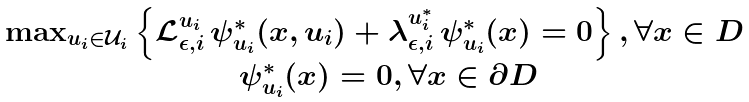Convert formula to latex. <formula><loc_0><loc_0><loc_500><loc_500>\begin{array} { c } \max _ { u _ { i } \in \mathcal { U } _ { i } } \left \{ \mathcal { L } _ { \epsilon , i } ^ { u _ { i } } \, \psi _ { u _ { i } } ^ { \ast } ( x , u _ { i } ) + \lambda _ { \epsilon , i } ^ { u _ { i } ^ { \ast } } \, \psi _ { u _ { i } } ^ { \ast } ( x ) = 0 \right \} , \forall x \in D \\ \quad \psi _ { u _ { i } } ^ { \ast } ( x ) = 0 , \forall x \in \partial D \\ \end{array}</formula> 